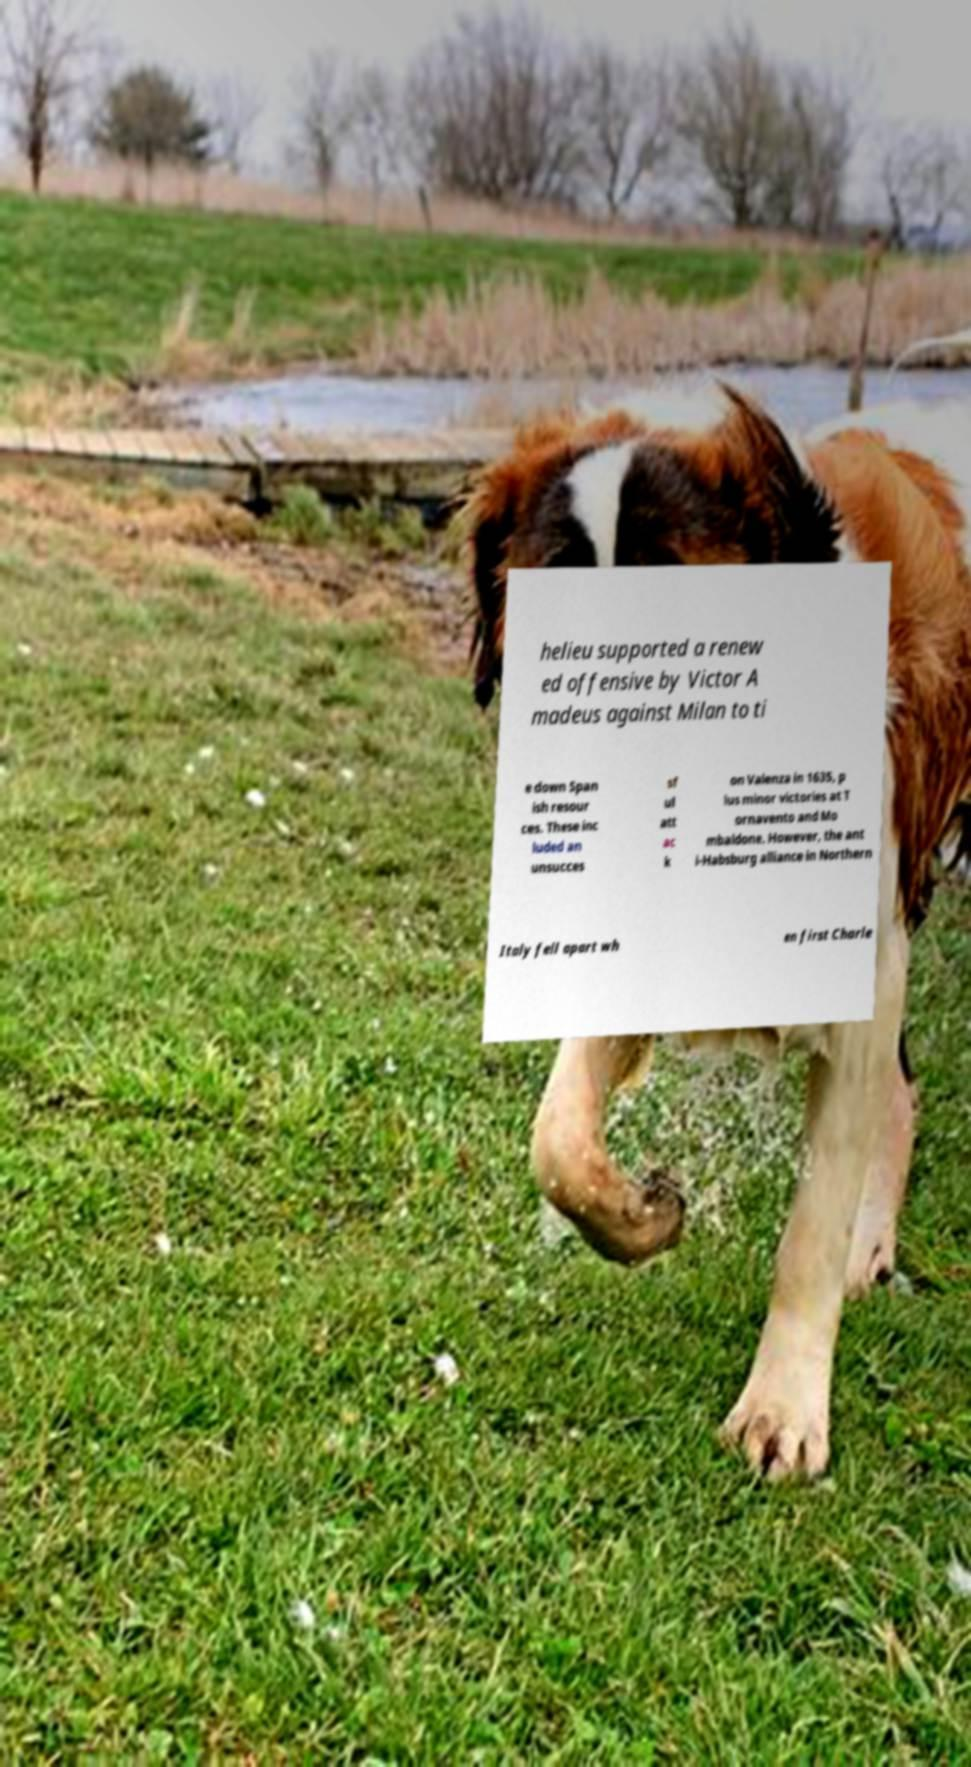Please read and relay the text visible in this image. What does it say? helieu supported a renew ed offensive by Victor A madeus against Milan to ti e down Span ish resour ces. These inc luded an unsucces sf ul att ac k on Valenza in 1635, p lus minor victories at T ornavento and Mo mbaldone. However, the ant i-Habsburg alliance in Northern Italy fell apart wh en first Charle 